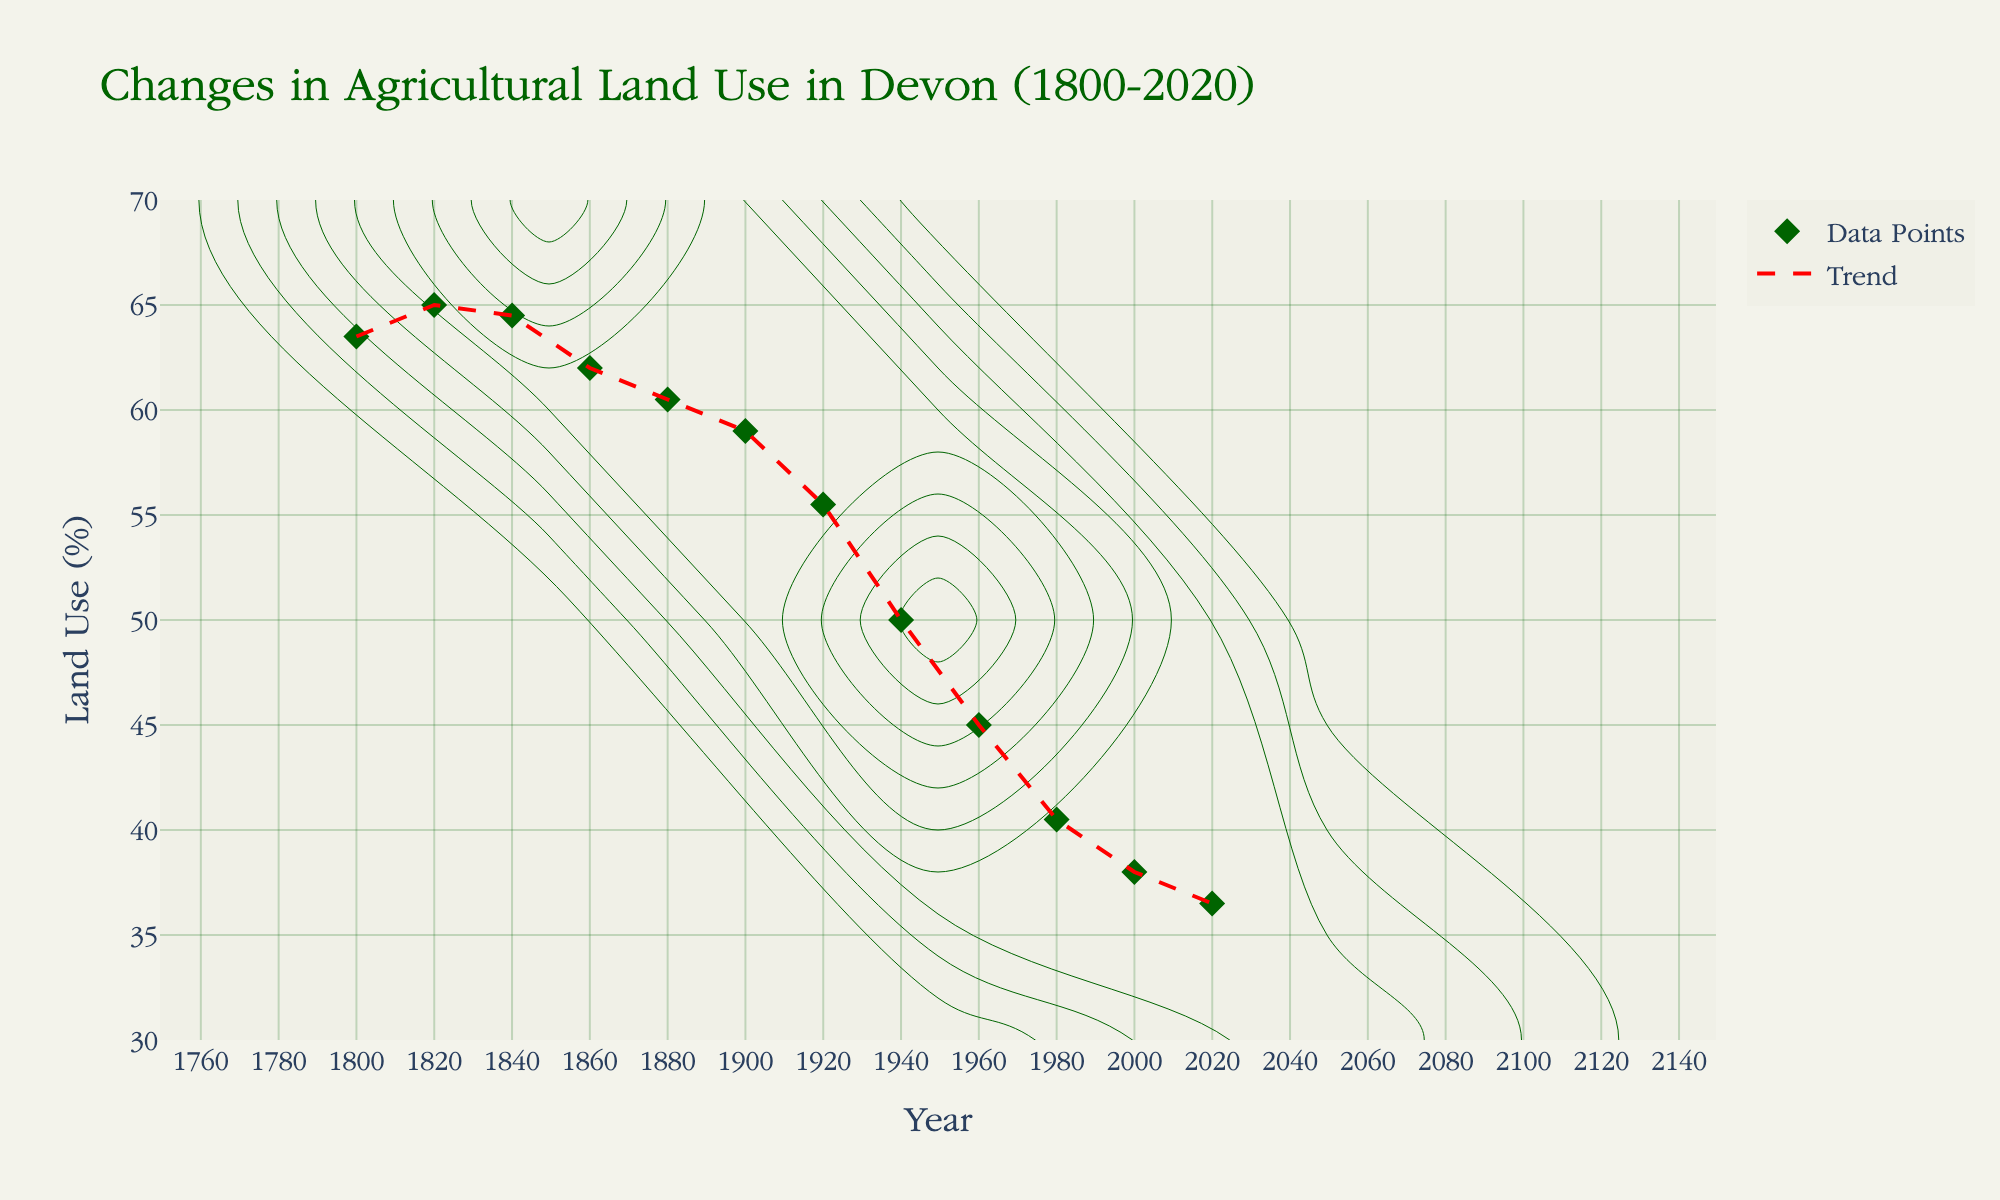What does the title of the plot indicate? The title of the plot typically indicates the focus of the graphical representation. Here, it highlights that the plot shows the changes in agricultural land use in Devon from 1800 to 2020.
Answer: Changes in Agricultural Land Use in Devon (1800-2020) What is the general trend of agricultural land use in Devon from 1800 to 2020? The general trend can be observed by looking at the line connecting the data points. It shows a downward trend, indicating a gradual decrease in the percentage of agricultural land use over the time period.
Answer: Decreasing How many major data points are plotted on the chart? The number of major data points refers to the key years specified in the data. By counting the markers on the plot, we see that there are 12 major data points.
Answer: 12 Between which years is the steepest decline in agricultural land use percentage observed? The steepest decline can be identified by finding the largest vertical drop between two consecutive data points. Here, between 1920 and 1940, the percentage drops from 55.5 to 50.0.
Answer: 1920 to 1940 What is the approximate percentage decrease in agricultural land use from 1800 to 2020? Calculate the difference in percentages from 1800 to 2020. Agricultural land use decreases from 63.5% in 1800 to 36.5% in 2020. Hence, the decrease is 63.5 - 36.5 = 27%.
Answer: 27% Which decade shows the smallest change in agricultural land use percentage? To find the smallest change, compare consecutive decades. From 1820 to 1840, the change is from 65% to 64.5%, a difference of 0.5%, which is the smallest among all periods.
Answer: 1820 to 1840 How does the agricultural land use percentage in 2000 compare to that in 1980? To compare the two percentages, look at the values for 1980 and 2000. In 1980, it is 40.5%, and in 2000, it is 38.0%. Thus, the percentage decreases by 2.5%.
Answer: It decreased by 2.5% Identify two intervals with roughly equal amounts of decline in agricultural land use. Compare the declines across different periods. From 1960 to 1980 and from 2000 to 2020, both intervals show a similar decline: 45.0% to 40.5% (4.5%) and 38.0% to 36.5% (1.5%), respectively. When recognizing changes here, the specific percentages and periods need careful comparison.
Answer: 1960 to 1980 and 2000 to 2020 What information does the red trend line provide in the plot? The red trend line is used to visually represent the general trend or pattern in the data. It shows a smoothed approximation of the overall decline in agricultural land use percentage over the years.
Answer: Overall declining trend What is the range for the y-axis, and what does it signify? The y-axis range, as observed, is from 30% to 70%. This range encompasses the agricultural land use percentage values plotted for the given years, indicating the highest and lowest percentages of agricultural land use over time.
Answer: 30% to 70% 